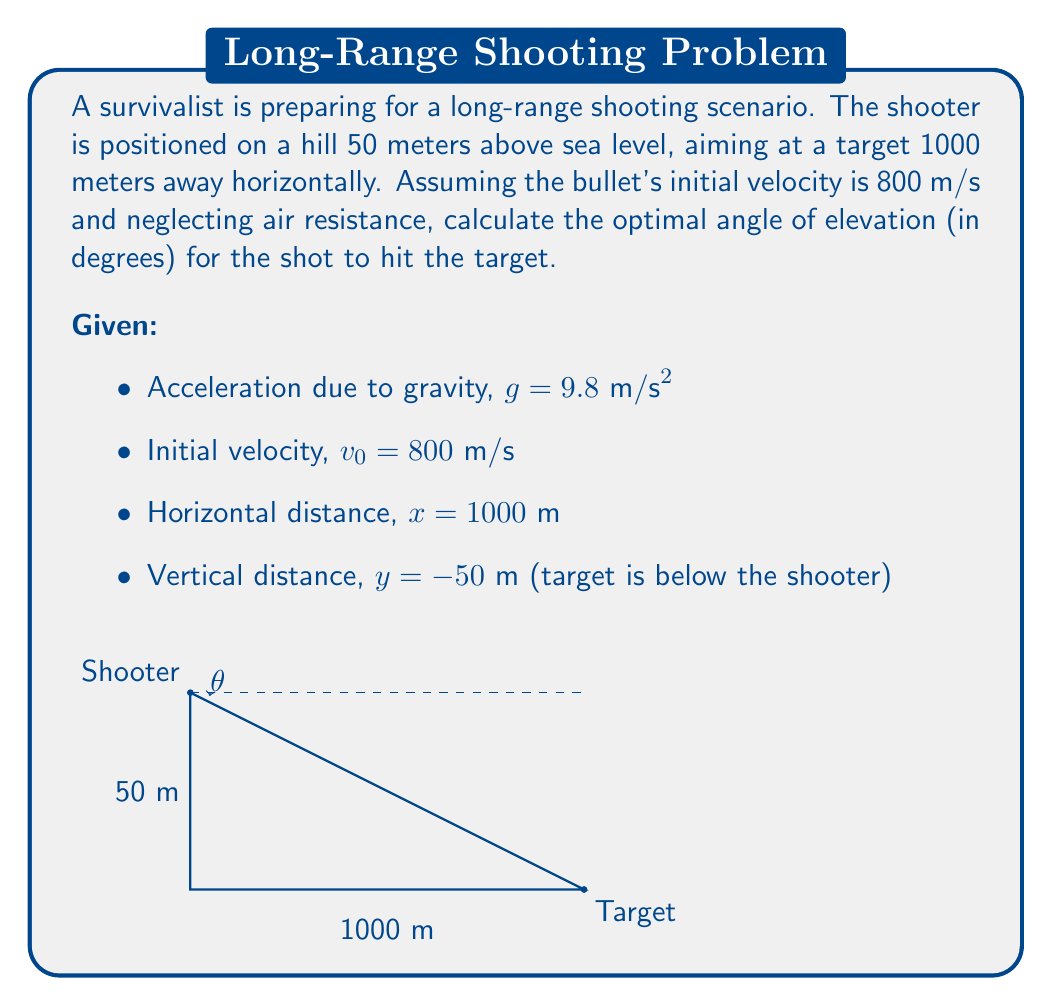Can you answer this question? To solve this problem, we'll use the equations of projectile motion and find the angle that allows the bullet to hit the target.

1) The equations of motion for a projectile are:
   $$x = v_0 \cos(\theta) \cdot t$$
   $$y = v_0 \sin(\theta) \cdot t - \frac{1}{2}gt^2$$

2) We know the horizontal distance $x = 1000$ m and the vertical distance $y = -50$ m (negative because the target is below the shooter).

3) From the x-equation, we can find the time of flight:
   $$t = \frac{x}{v_0 \cos(\theta)} = \frac{1000}{800 \cos(\theta)}$$

4) Substituting this into the y-equation:
   $$-50 = v_0 \sin(\theta) \cdot \frac{1000}{800 \cos(\theta)} - \frac{1}{2}g\left(\frac{1000}{800 \cos(\theta)}\right)^2$$

5) Simplifying and rearranging:
   $$-50 = 1000 \tan(\theta) - \frac{1000000g}{2(800\cos(\theta))^2}$$

6) Multiply both sides by $2\cos^2(\theta)$:
   $$-100\cos^2(\theta) = 2000\sin(\theta)\cos(\theta) - \frac{1000000g}{640000}$$

7) Using the identity $\sin(2\theta) = 2\sin(\theta)\cos(\theta)$:
   $$-100\cos^2(\theta) = 1000\sin(2\theta) - 15.3125$$

8) This equation can be solved numerically. Using a computer algebra system or graphing calculator, we find:

   $\theta \approx 0.0878$ radians

9) Convert to degrees:
   $$\theta = 0.0878 \cdot \frac{180}{\pi} \approx 5.03°$$
Answer: The optimal angle of elevation for the long-range shot is approximately 5.03°. 